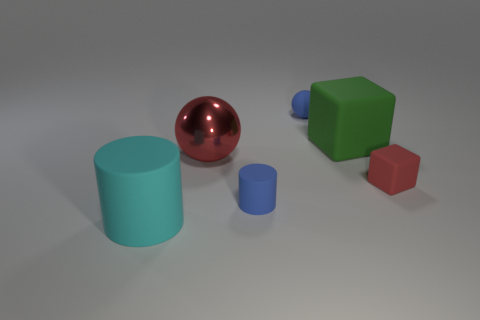Subtract all blue balls. How many balls are left? 1 Subtract all small things. Subtract all tiny blue objects. How many objects are left? 1 Add 6 big matte blocks. How many big matte blocks are left? 7 Add 1 red spheres. How many red spheres exist? 2 Add 2 large green spheres. How many objects exist? 8 Subtract 1 blue balls. How many objects are left? 5 Subtract all blocks. How many objects are left? 4 Subtract 1 spheres. How many spheres are left? 1 Subtract all gray spheres. Subtract all yellow cylinders. How many spheres are left? 2 Subtract all cyan cylinders. How many red spheres are left? 1 